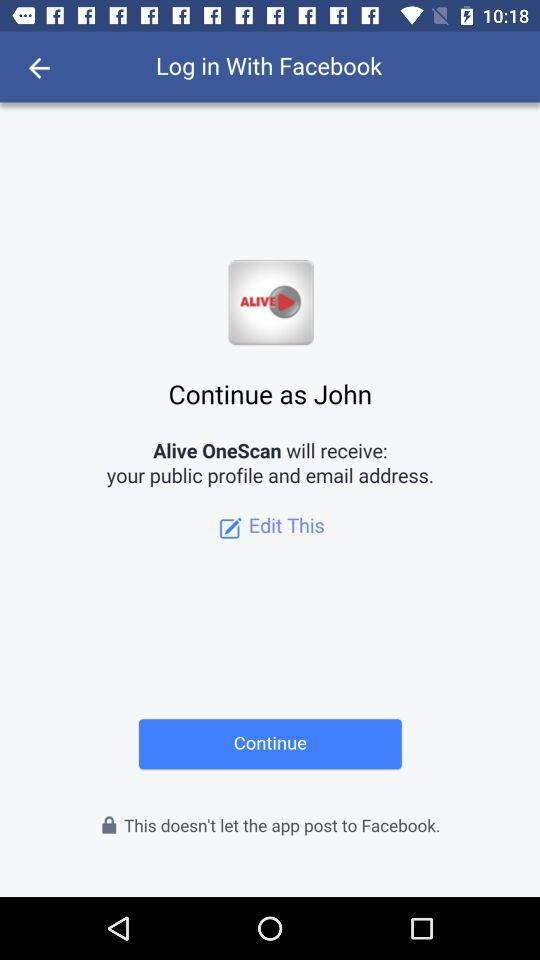What application is asking for permission? The application that is asking for permission is "Alive OneScan". 